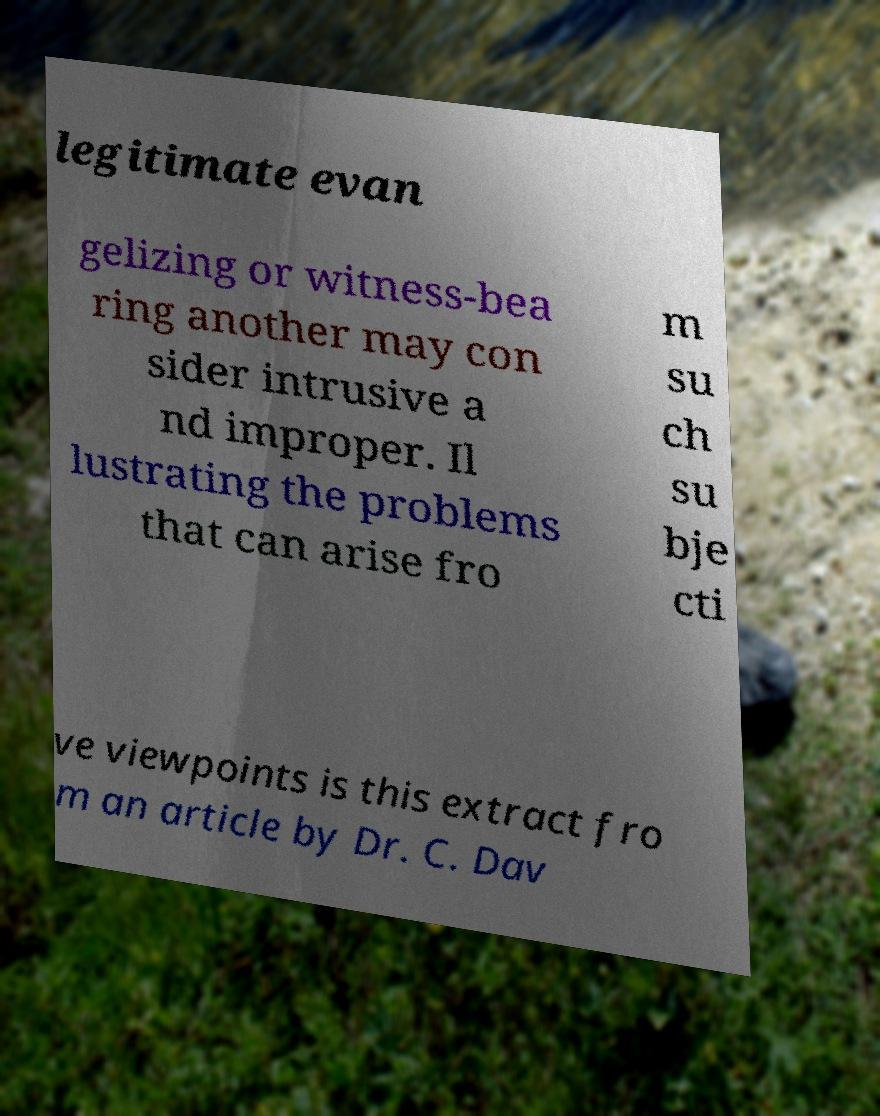Could you assist in decoding the text presented in this image and type it out clearly? legitimate evan gelizing or witness-bea ring another may con sider intrusive a nd improper. Il lustrating the problems that can arise fro m su ch su bje cti ve viewpoints is this extract fro m an article by Dr. C. Dav 